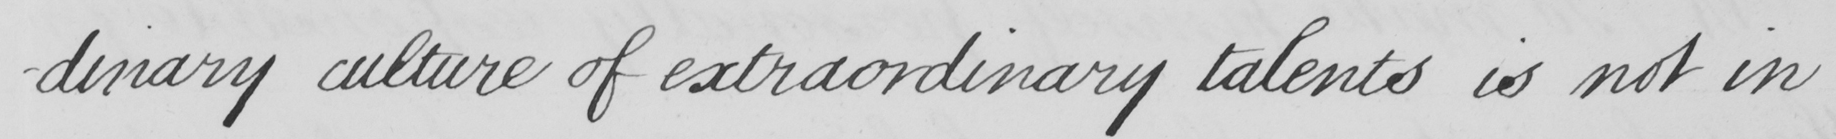Transcribe the text shown in this historical manuscript line. -dinary culture of extraordinary talents is not in 